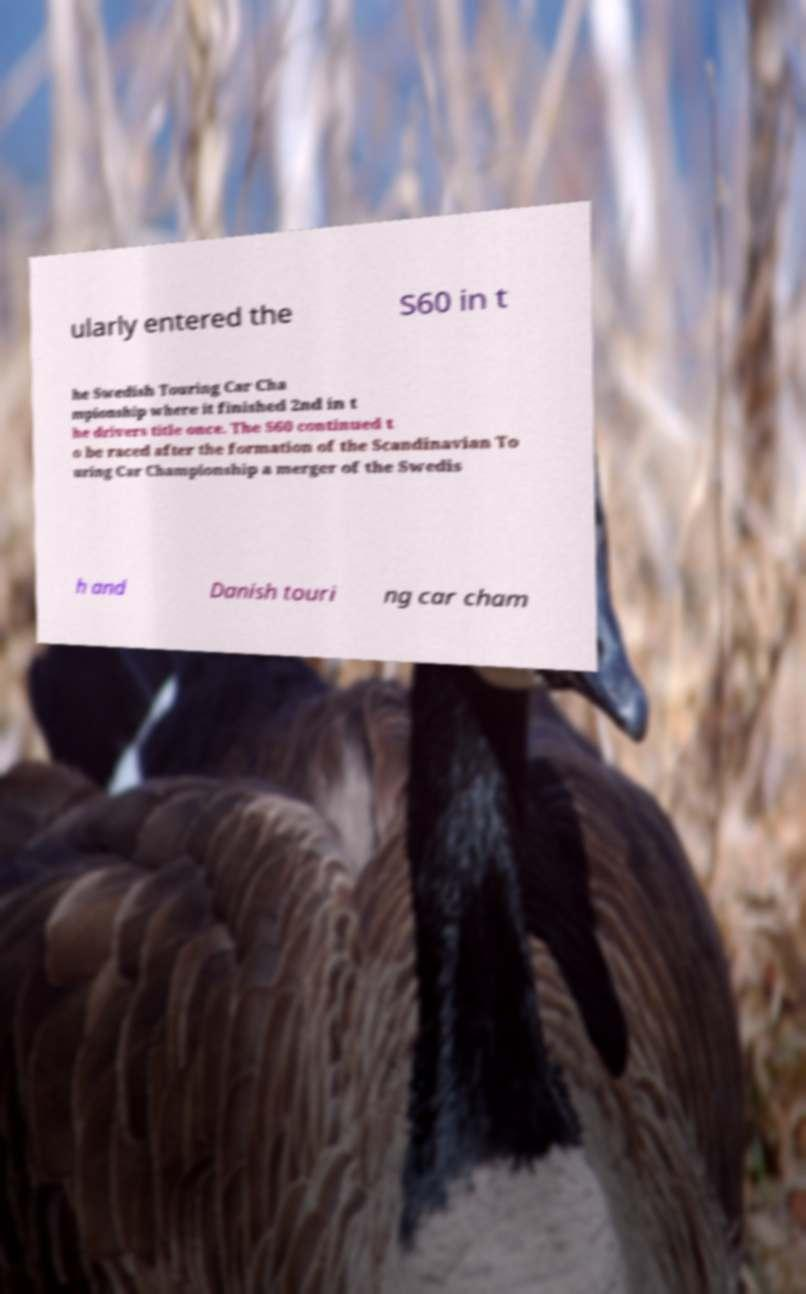Please read and relay the text visible in this image. What does it say? ularly entered the S60 in t he Swedish Touring Car Cha mpionship where it finished 2nd in t he drivers title once. The S60 continued t o be raced after the formation of the Scandinavian To uring Car Championship a merger of the Swedis h and Danish touri ng car cham 